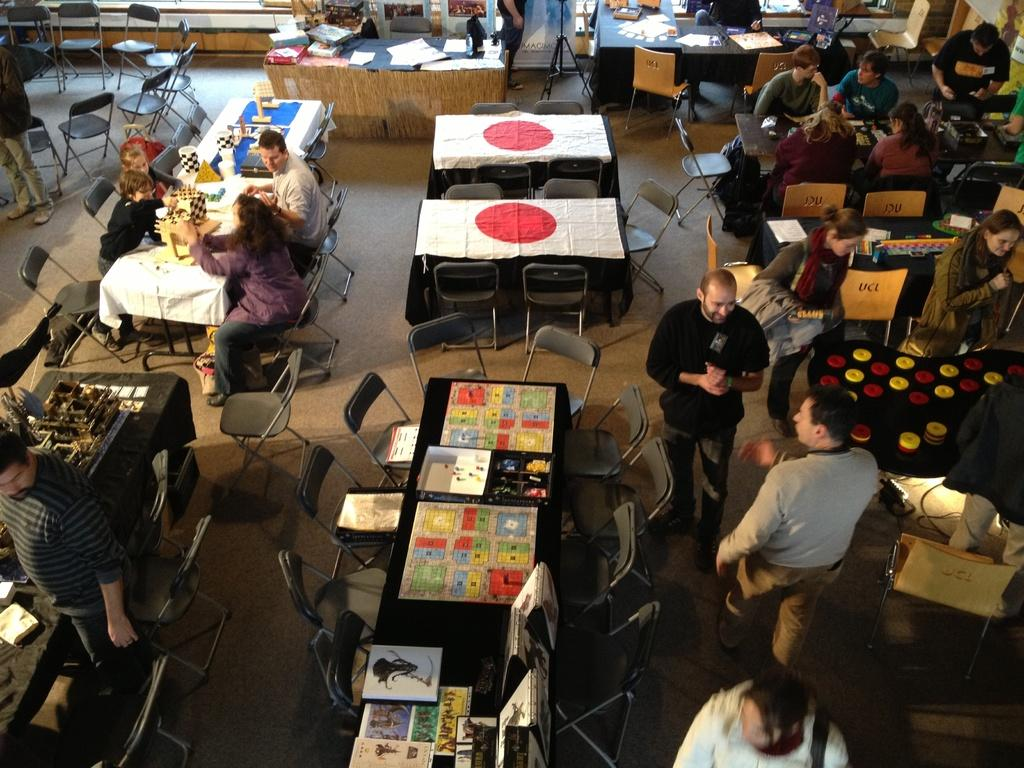Who or what is present in the image? There are people in the image. What are the people doing in the image? The people are sitting on chairs. How are the chairs arranged in the image? The chairs are arranged around a table. What type of stage can be seen in the image? There is no stage present in the image; it features people sitting on chairs arranged around a table. 